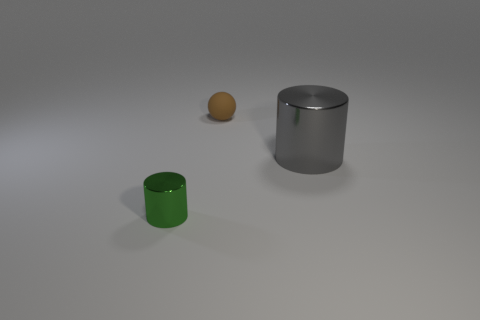Are there the same number of big gray metal cylinders to the left of the big gray cylinder and gray objects that are left of the tiny shiny cylinder? From the given perspective in the image, to the left of the large gray cylinder, there is just one big gray metal cylinder. However, if considering 'left' from the cylinder's own perspective, there would be none. In relation to the tiny shiny cylinder, which could be assumed to be the small orange sphere-like object given no cylinder fits that description, there are no gray objects directly to its left from the viewer's point of view. Therefore, with respect to the viewer's perspective, the answer is no, there are not the same number of big gray metal cylinders to the left of the big gray cylinder as there are gray objects left of the tiny shiny cylinder, mainly because there are no cylinders to compare in size or color to the tiny shiny object. 